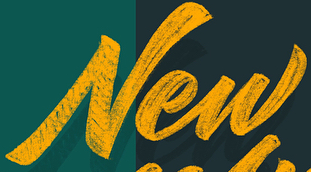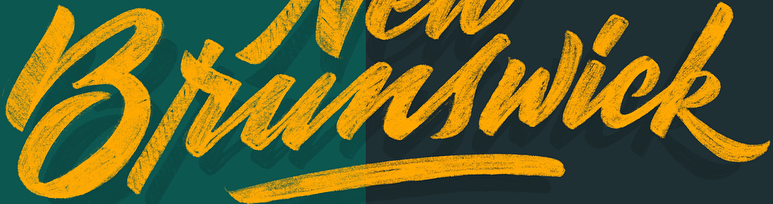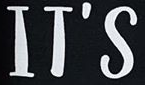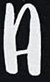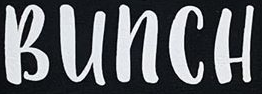Read the text from these images in sequence, separated by a semicolon. New; Brunswick; IT'S; A; BUNCH 